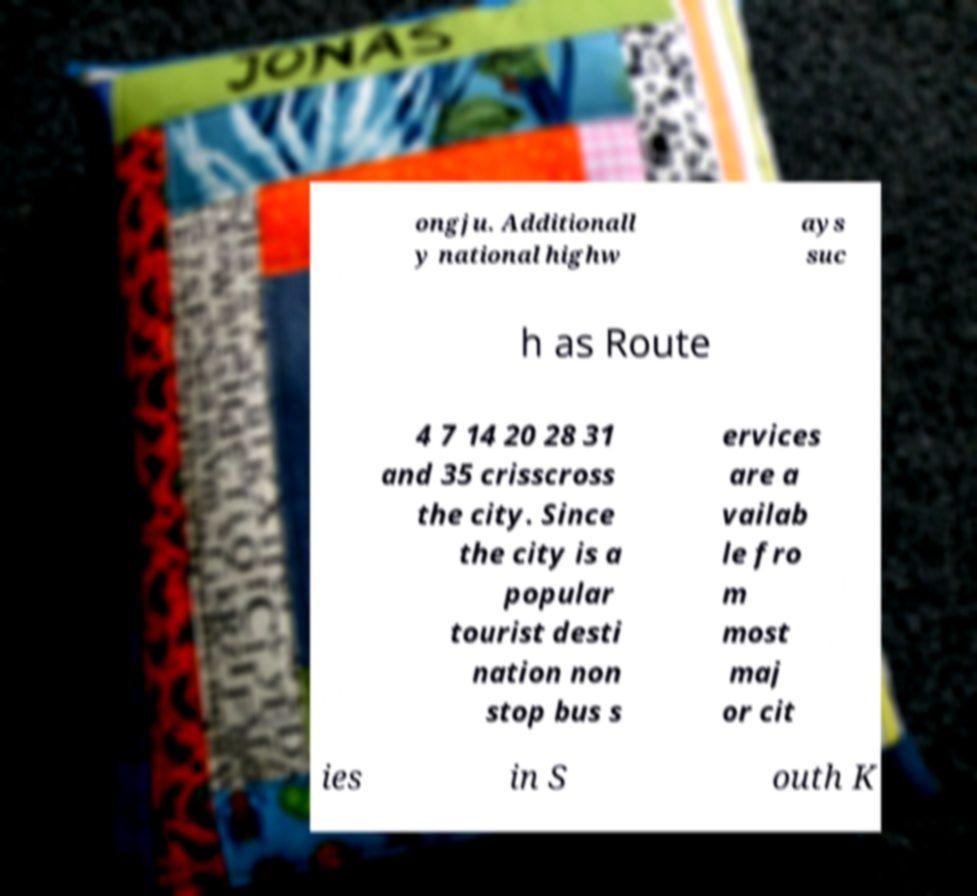Could you assist in decoding the text presented in this image and type it out clearly? ongju. Additionall y national highw ays suc h as Route 4 7 14 20 28 31 and 35 crisscross the city. Since the city is a popular tourist desti nation non stop bus s ervices are a vailab le fro m most maj or cit ies in S outh K 